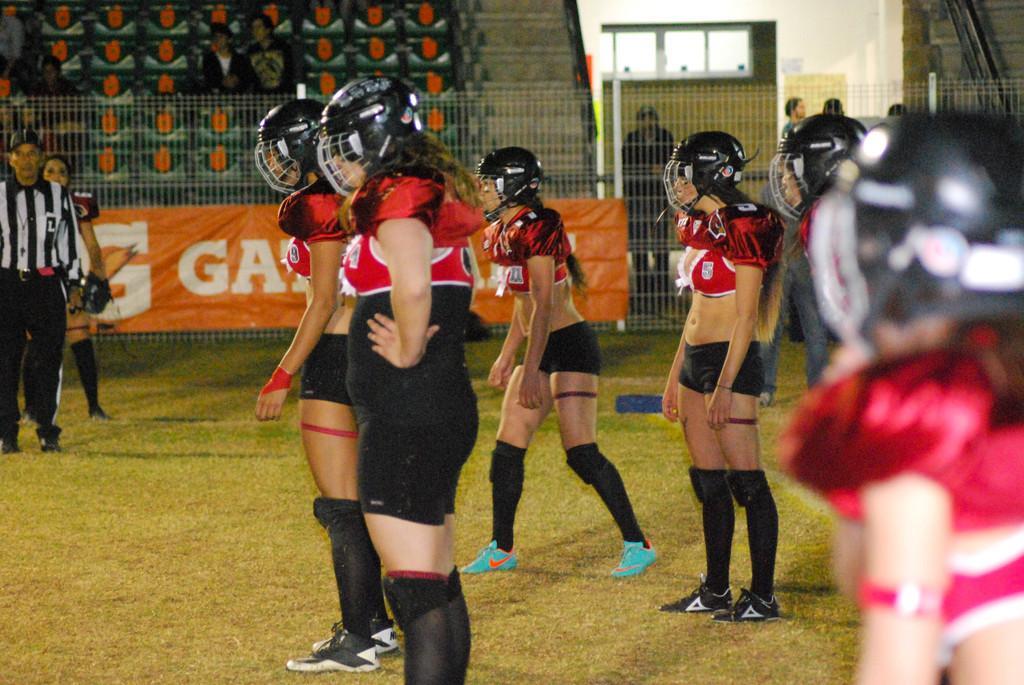Could you give a brief overview of what you see in this image? In this image we can see a group of people standing in the grass wearing helmets, there we can see a referee, a fence, few people in the stands, windows and few people are standing. 